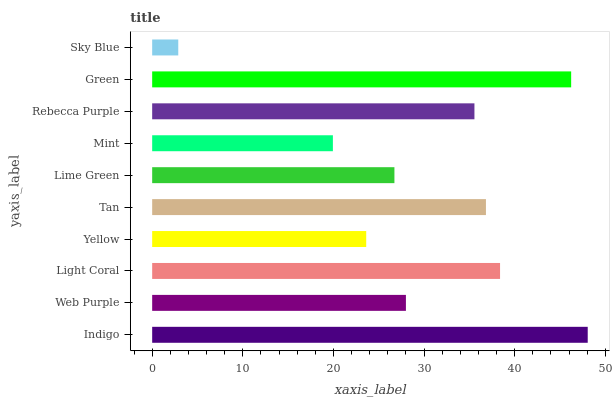Is Sky Blue the minimum?
Answer yes or no. Yes. Is Indigo the maximum?
Answer yes or no. Yes. Is Web Purple the minimum?
Answer yes or no. No. Is Web Purple the maximum?
Answer yes or no. No. Is Indigo greater than Web Purple?
Answer yes or no. Yes. Is Web Purple less than Indigo?
Answer yes or no. Yes. Is Web Purple greater than Indigo?
Answer yes or no. No. Is Indigo less than Web Purple?
Answer yes or no. No. Is Rebecca Purple the high median?
Answer yes or no. Yes. Is Web Purple the low median?
Answer yes or no. Yes. Is Yellow the high median?
Answer yes or no. No. Is Light Coral the low median?
Answer yes or no. No. 